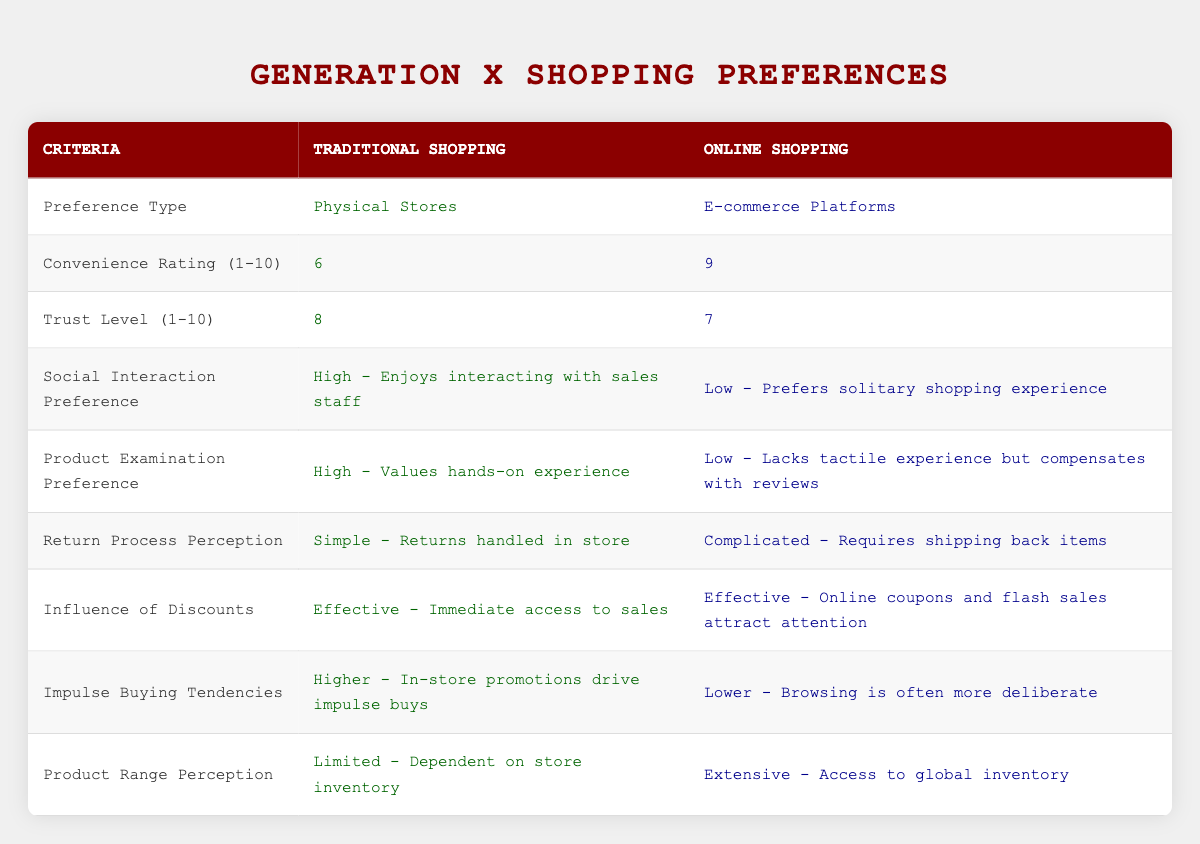What is the convenience rating for traditional shopping? The convenience rating for traditional shopping is explicitly stated in the table under the corresponding row for "Convenience Rating (1-10)," where it shows a value of 6.
Answer: 6 What type of shopping do Generation X individuals prefer for social interaction? The table indicates that traditional shopping is preferred for social interaction, as it states "High - Enjoys interacting with sales staff."
Answer: Traditional shopping Which shopping method has a higher trust level according to the table? Looking at the "Trust Level (1-10)" row, traditional shopping has a trust level of 8, while online shopping has a trust level of 7, indicating that traditional shopping is preferred in terms of trust.
Answer: Traditional shopping Do online shopping platforms have an effective influence of discounts? The table confirms that online shopping is effective in terms of discounts as it notes, "Effective - Online coupons and flash sales attract attention," indicating that discounts do influence this shopping method.
Answer: Yes What is the difference in impulse buying tendencies between traditional and online shopping? According to the table, traditional shopping has "Higher - In-store promotions drive impulse buys" compared to "Lower - Browsing is often more deliberate" for online shopping, indicating that the difference is in the level of impulse buying tendency.
Answer: Higher Based on the table, what is the average convenience rating of traditional and online shopping? To find the average, sum the convenience ratings: 6 (traditional) + 9 (online) = 15. Dividing by the number of shopping methods (2), the average is 15/2 = 7.5.
Answer: 7.5 Which shopping method is perceived to have a simpler return process? The table indicates that traditional shopping is perceived as "Simple - Returns handled in store" whereas online shopping is marked as "Complicated - Requires shipping back items," meaning traditional shopping has the simpler process.
Answer: Traditional shopping How do the product range perceptions differ between traditional and online shopping according to the table? The table illustrates that traditional shopping has a "Limited - Dependent on store inventory" perception while online shopping has "Extensive - Access to global inventory," indicating a significant difference in product range availability.
Answer: Traditional shopping is limited; online shopping is extensive In terms of product examination preference, which shopping method values hands-on experience more? The table provides insight that traditional shopping values hands-on experience with "High - Values hands-on experience," contrasting with online shopping's "Low - Lacks tactile experience but compensates with reviews," showing a clear preference for traditional shopping.
Answer: Traditional shopping 